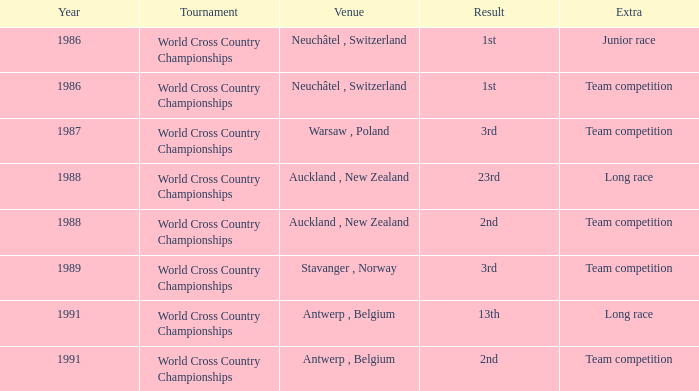Which location had an additional team competition and a outcome of 1st? Neuchâtel , Switzerland. 